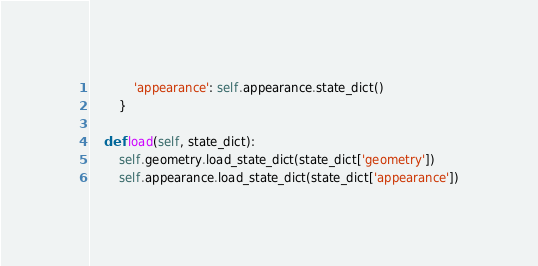<code> <loc_0><loc_0><loc_500><loc_500><_Python_>            'appearance': self.appearance.state_dict()
        }
    
    def load(self, state_dict):
        self.geometry.load_state_dict(state_dict['geometry'])
        self.appearance.load_state_dict(state_dict['appearance'])
</code> 